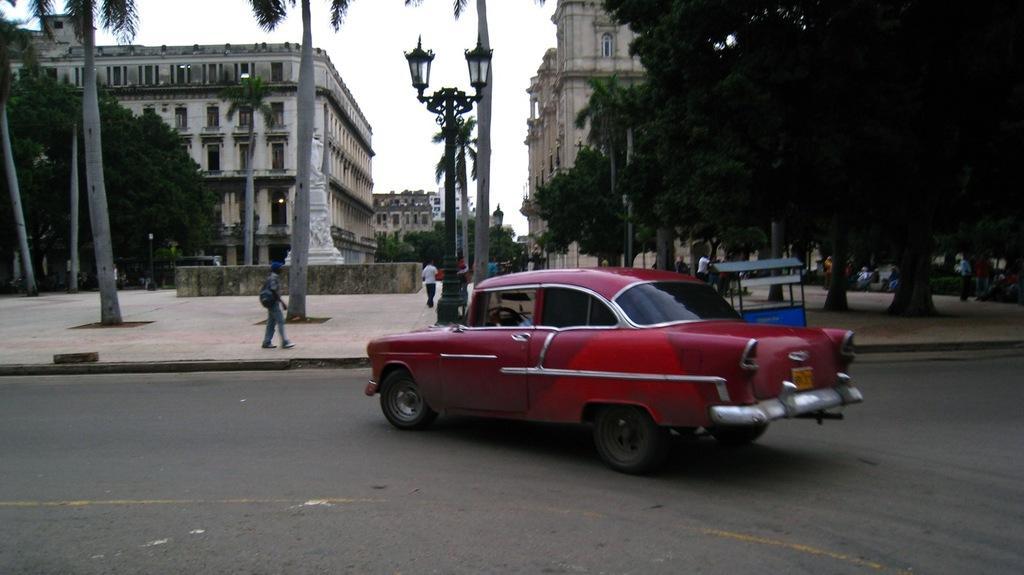In one or two sentences, can you explain what this image depicts? In the image we can see a vehicle on the road. There are even people walking and they are wearing clothes. Here we can see trees, buildings and these are the windows of the buildings. Here we can see the pole, road and the sky. 